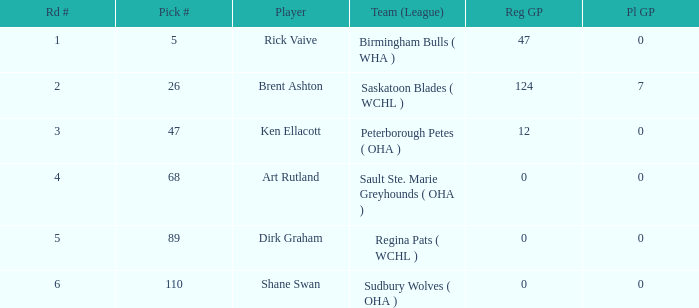Would you be able to parse every entry in this table? {'header': ['Rd #', 'Pick #', 'Player', 'Team (League)', 'Reg GP', 'Pl GP'], 'rows': [['1', '5', 'Rick Vaive', 'Birmingham Bulls ( WHA )', '47', '0'], ['2', '26', 'Brent Ashton', 'Saskatoon Blades ( WCHL )', '124', '7'], ['3', '47', 'Ken Ellacott', 'Peterborough Petes ( OHA )', '12', '0'], ['4', '68', 'Art Rutland', 'Sault Ste. Marie Greyhounds ( OHA )', '0', '0'], ['5', '89', 'Dirk Graham', 'Regina Pats ( WCHL )', '0', '0'], ['6', '110', 'Shane Swan', 'Sudbury Wolves ( OHA )', '0', '0']]} How many standard gp did rick vaive have in round one? None. 